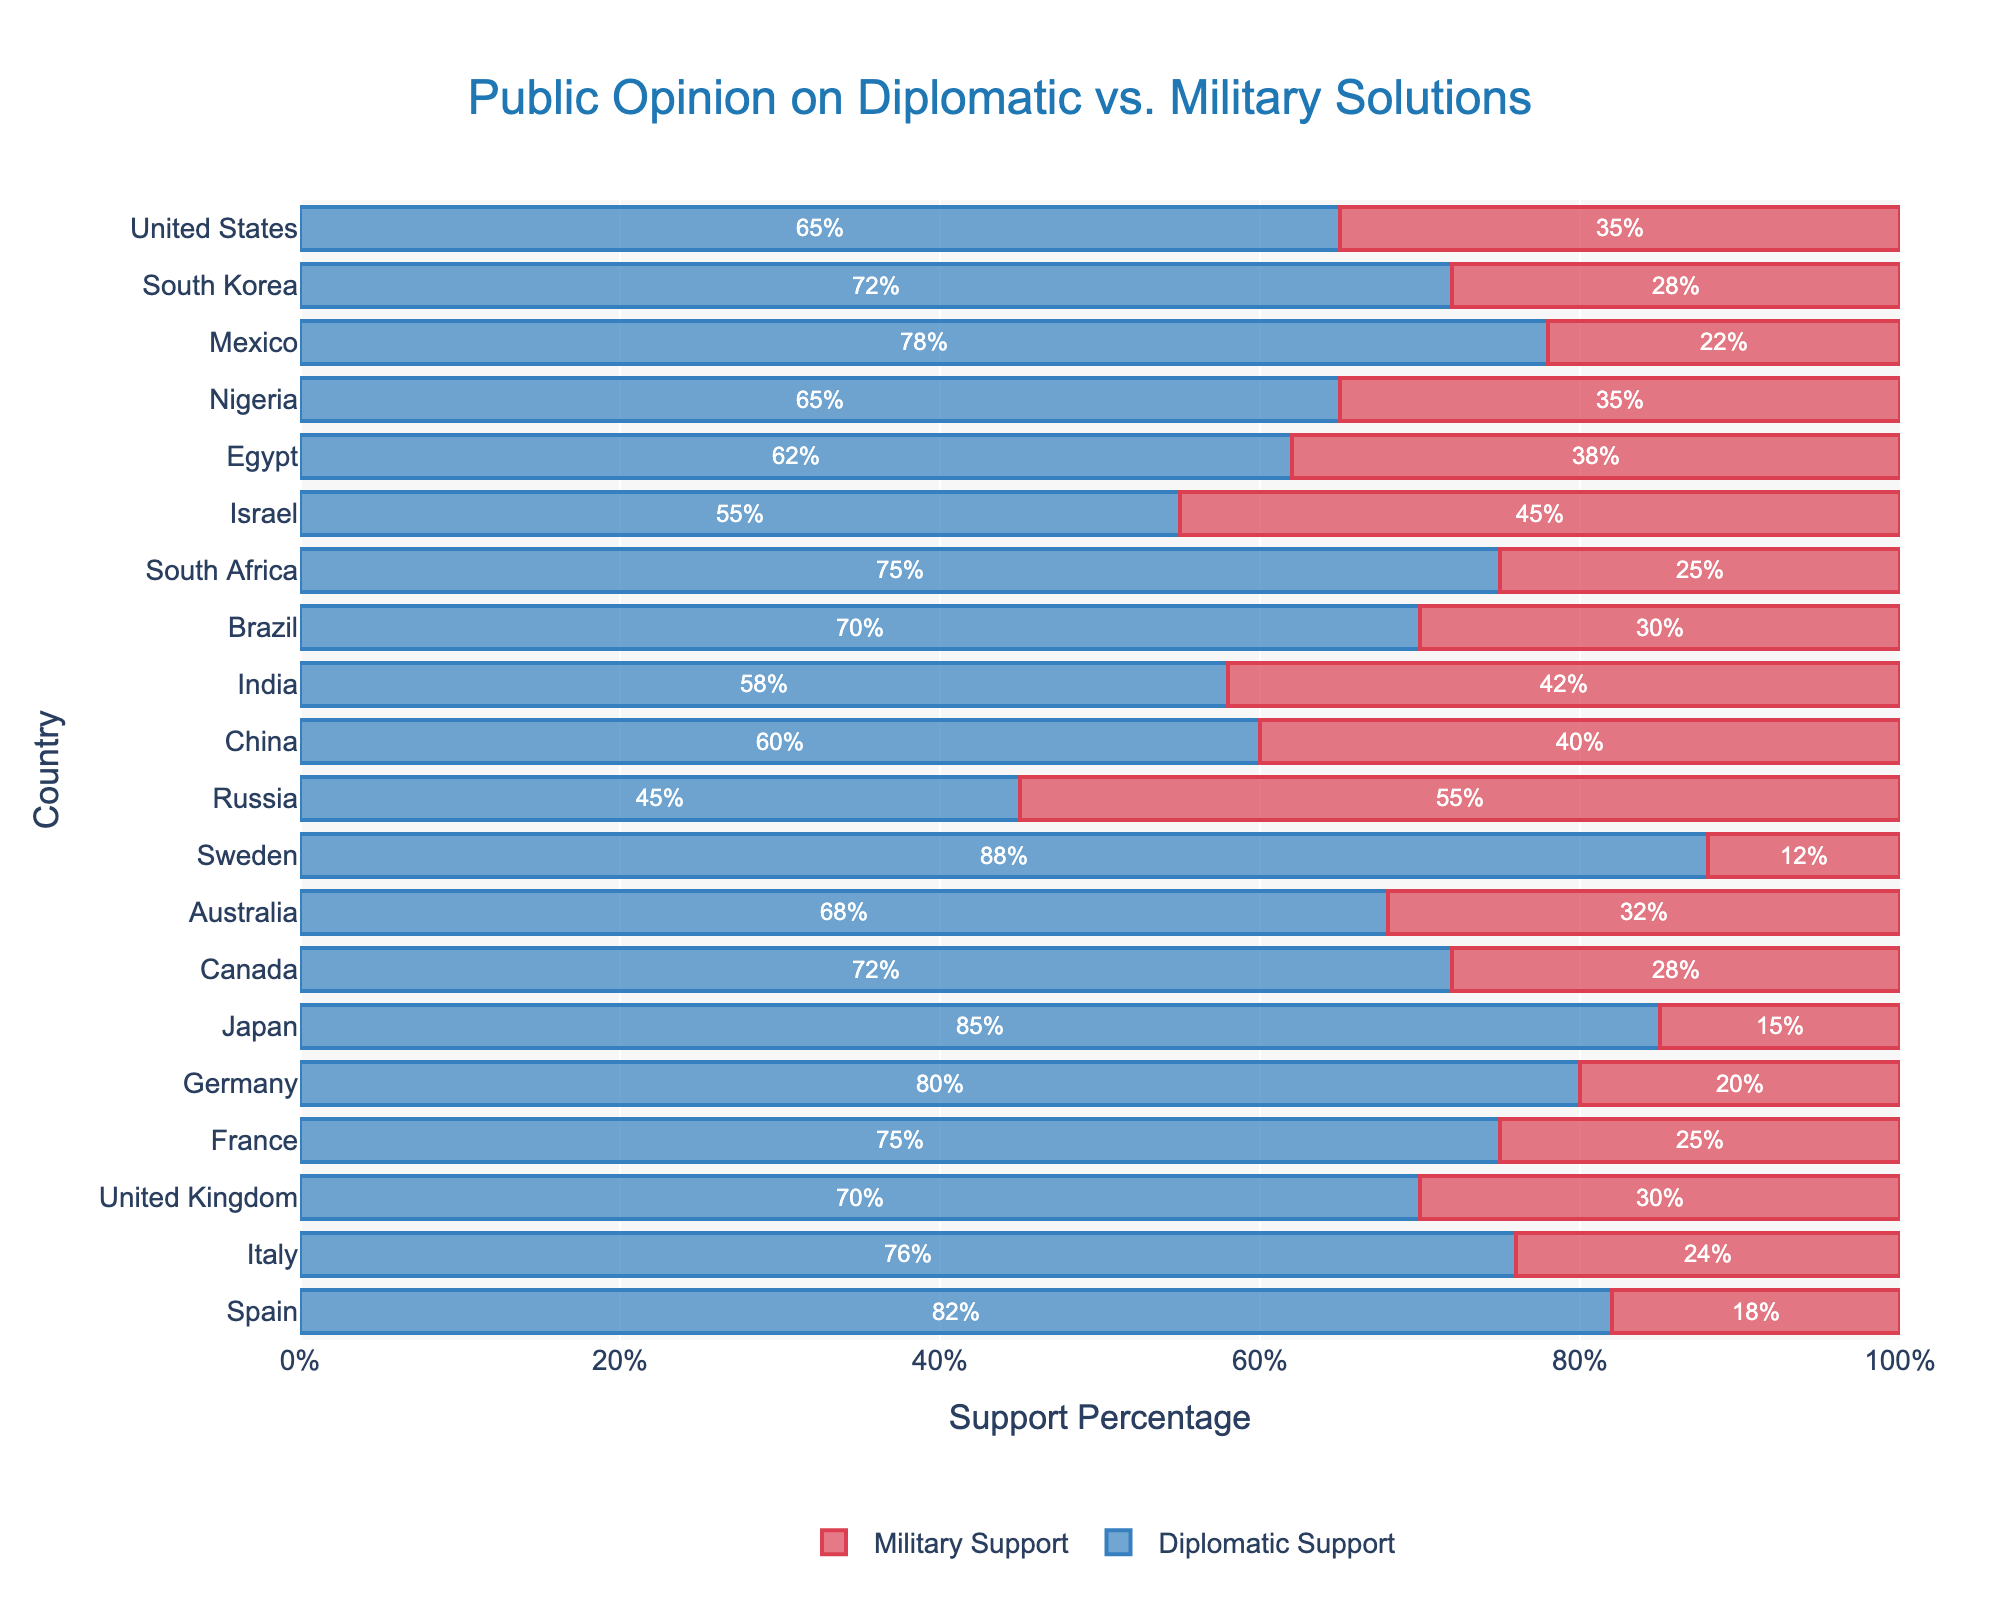What is the main title of the plot? The main title is located at the top center of the plot and is prominently labeled for easy reference.
Answer: Public Opinion on Diplomatic vs. Military Solutions Which country has the highest support for diplomatic solutions? Look for the country with the longest bar in the "Diplomatic Support" section, which is Sweden at 88%.
Answer: Sweden What are the support percentages for diplomatic and military solutions in the United States? Identify the bars corresponding to the United States and read the percentages labeled on them, which show 65% for diplomatic and 35% for military solutions.
Answer: Diplomatic: 65%, Military: 35% How many countries have more than 70% support for diplomatic solutions? Count the number of countries where the diplomatic support bar extends beyond the 70% mark. These countries are Japan, Sweden, Germany, Mexico, and Spain.
Answer: 5 countries Which country has the closest level of support between diplomatic and military solutions? Compare the lengths of the bars for each country to find the one where the diplomatic and military supports are most similar. In this case, Russia has 45% diplomatic and 55% military support.
Answer: Russia What is the total support for diplomatic and military solutions in Brazil? Add the percentages for diplomatic and military support for Brazil. Diplomatic: 70%, Military: 30%. So, 70 + 30.
Answer: 100% Which country has the lowest support for military solutions? Look for the shortest bar in the "Military Support" section. The country is Sweden with 12%.
Answer: Sweden Among Germany, Japan, and Canada, which country has the lowest support for military solutions? Compare the military support percentages of Germany, Japan, and Canada. Germany: 20%, Japan: 15%, Canada: 28%.
Answer: Japan What is the average diplomatic support across all countries? Sum all the diplomatic support percentages and divide by the number of countries (20). (65+70+75+80+85+72+68+88+45+60+58+70+75+55+62+65+78+72+76+82)/20 = 70
Answer: 70% Is there a country with equal support levels for both diplomatic and military solutions? Examine the support percentages for each country to see if any have identical levels for both solutions. In the data, no country has equal percentages for diplomatic and military support.
Answer: No 